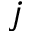<formula> <loc_0><loc_0><loc_500><loc_500>j</formula> 